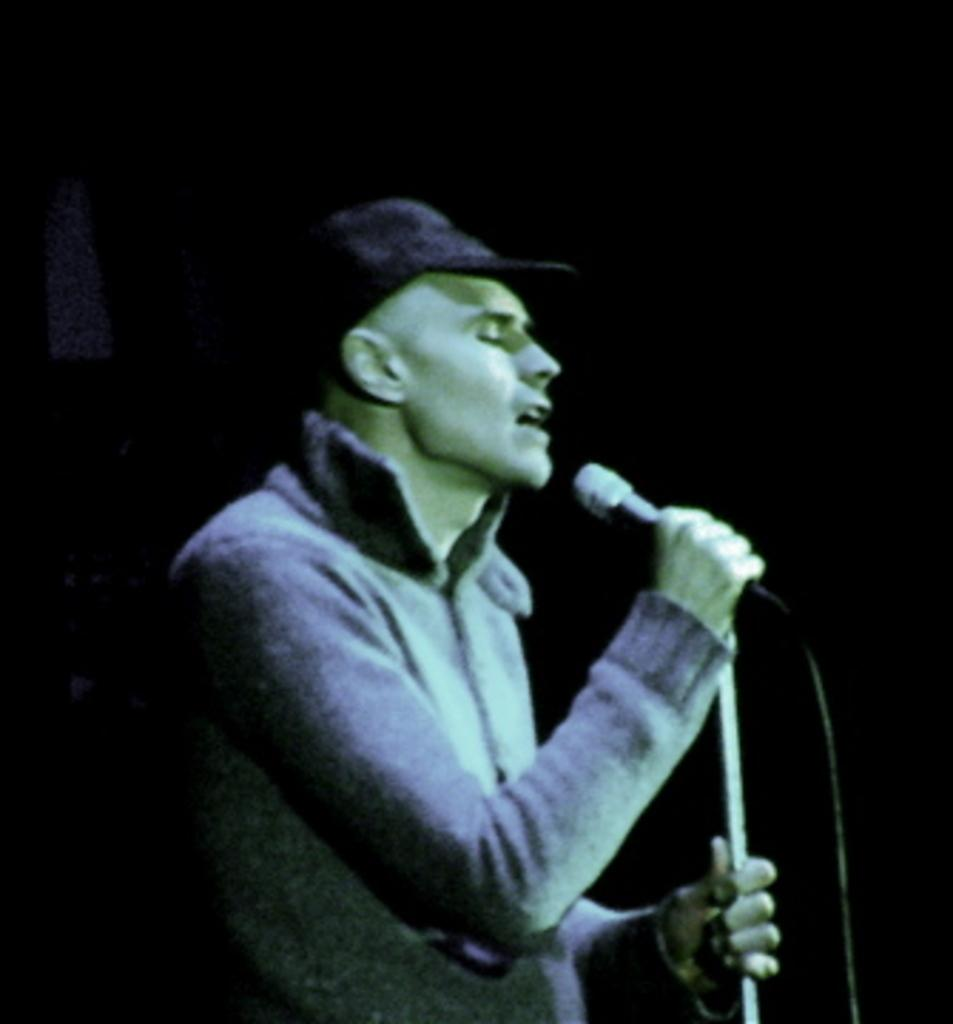Who is present in the image? There is a man in the image. What is the man wearing? The man is wearing clothes and a cap. What is the man holding in his hand? The man is holding a microphone in his hand. Can you describe any additional details about the image? There is a cable wire visible in the image, and the background of the image is blurred. How many pets are visible in the image? There are no pets present in the image. What type of pencil is the man using to write on the microphone? The man is not using a pencil in the image; he is holding a microphone. 